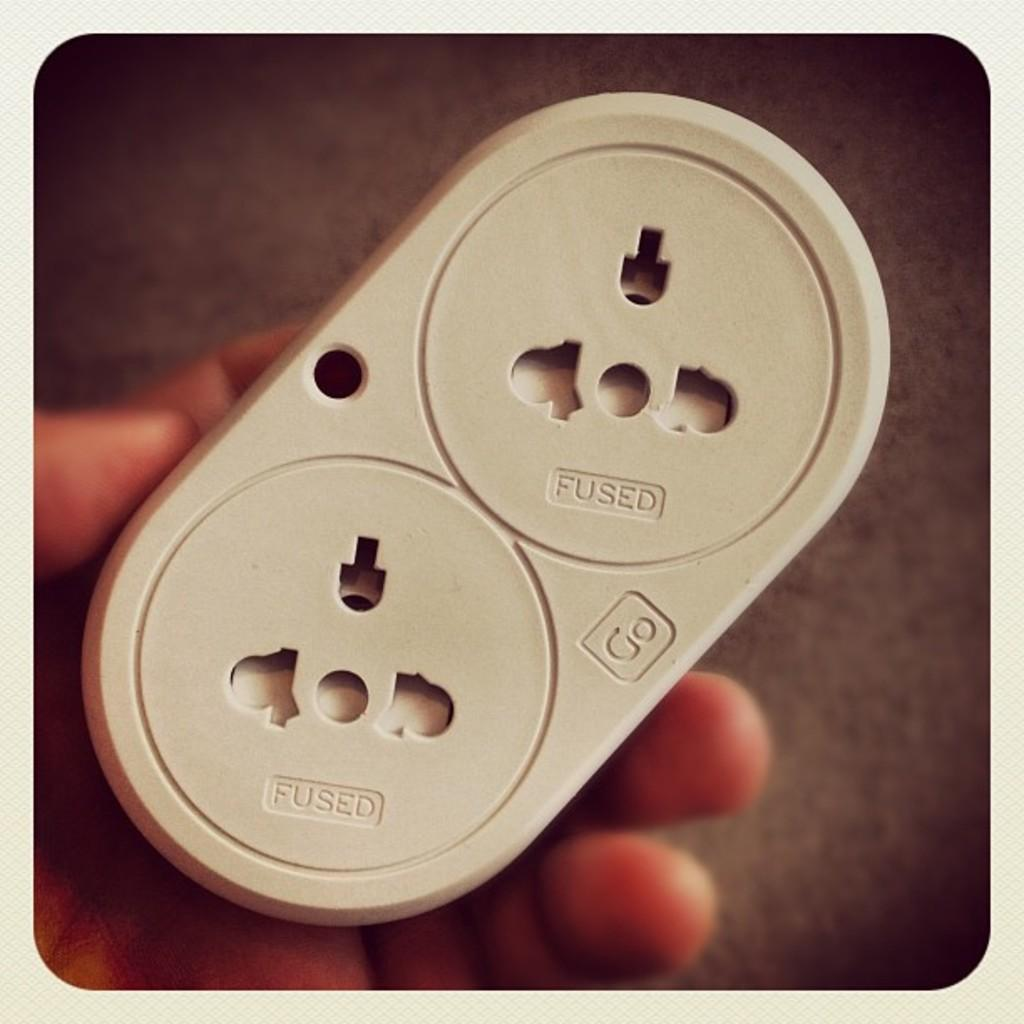<image>
Summarize the visual content of the image. Person holding a power switch that says the word FUSED on it. 